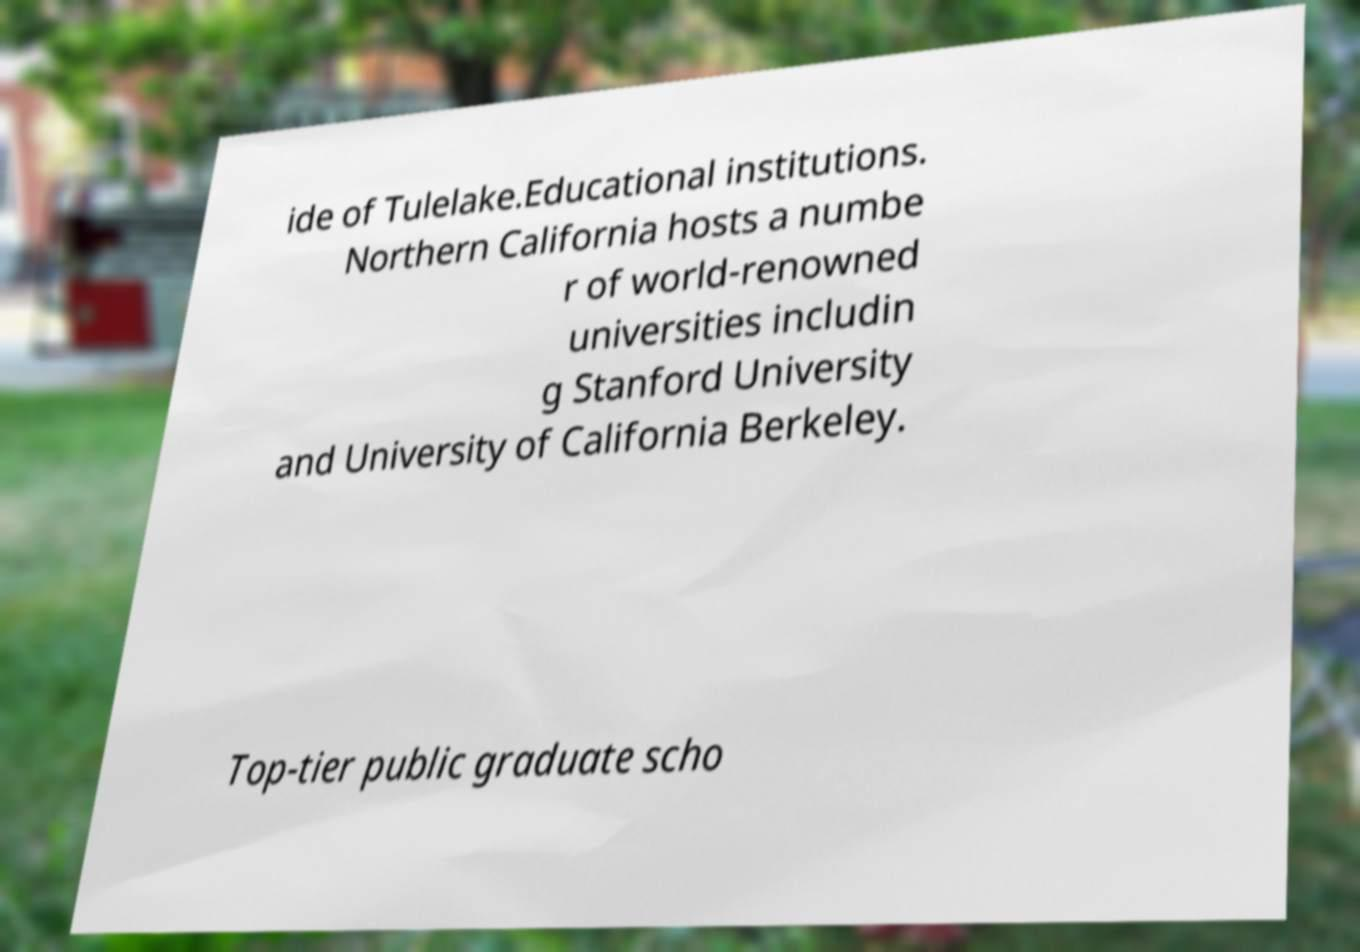Could you extract and type out the text from this image? ide of Tulelake.Educational institutions. Northern California hosts a numbe r of world-renowned universities includin g Stanford University and University of California Berkeley. Top-tier public graduate scho 